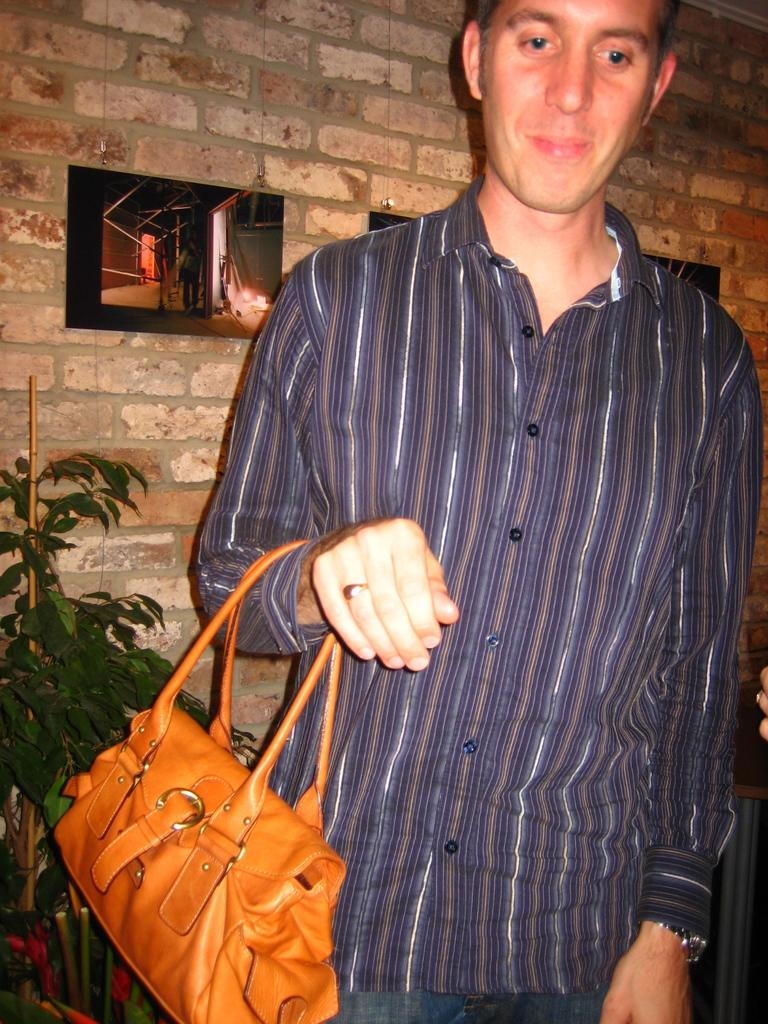Who is the person in the image? There is a man in the image. What is the man holding in the image? The man is holding a handbag. What type of vegetation can be seen in the image? There is a plant visible in the image. What is on the wall in the image? There is something on the wall in the image. What is the name of the game being played by the man in the image? There is no game being played in the image, and the man is not engaged in any game-related activity. 